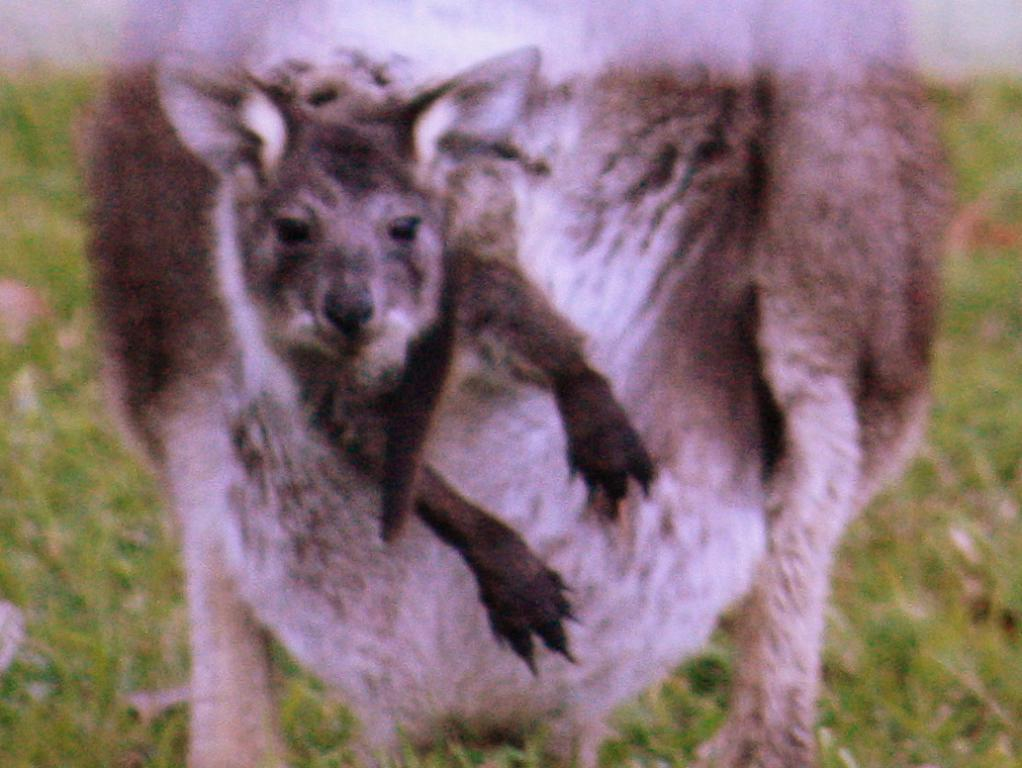What type of animal is in the image? The animal in the image is not specified, but it has brown, black, and white coloring. What is the color pattern of the animal? The animal has brown, black, and white coloring. What type of terrain is visible in the image? There is grass on the ground in the image. How much profit does the animal generate in the image? There is no information about profit in the image, as it features an animal with a specific color pattern and grass on the ground. 